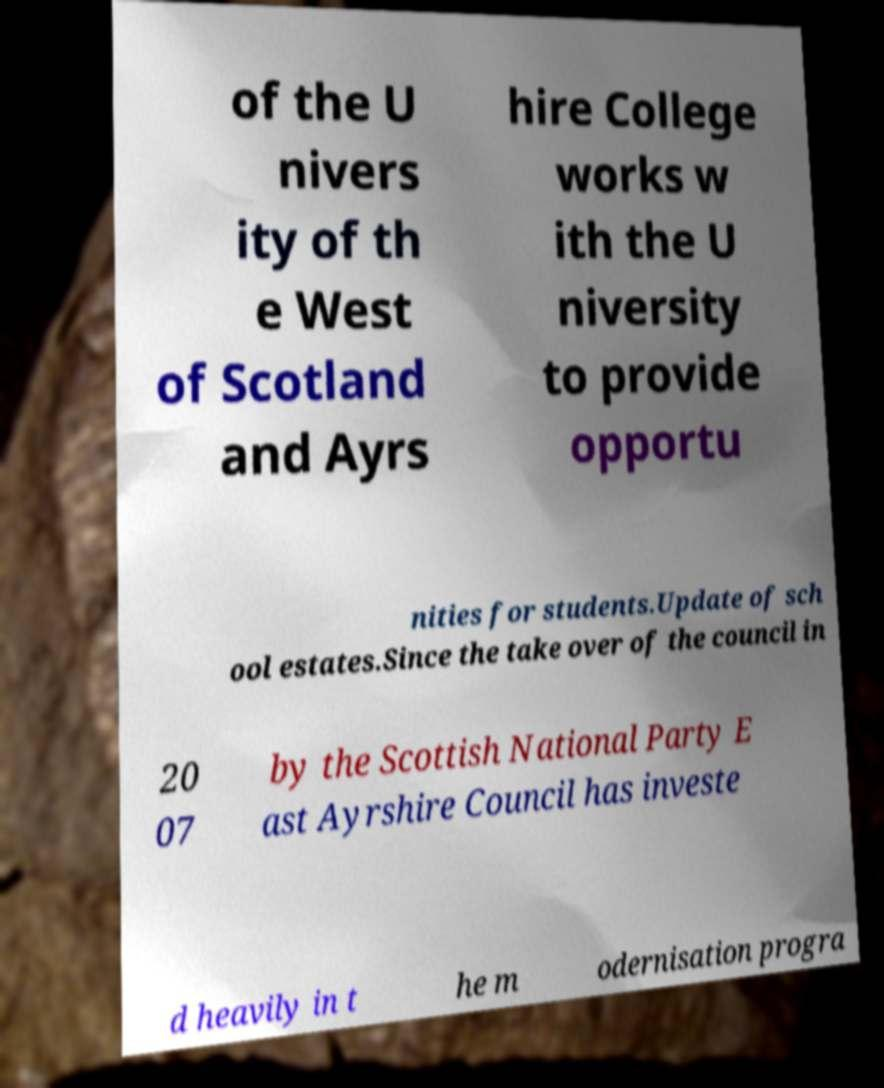There's text embedded in this image that I need extracted. Can you transcribe it verbatim? of the U nivers ity of th e West of Scotland and Ayrs hire College works w ith the U niversity to provide opportu nities for students.Update of sch ool estates.Since the take over of the council in 20 07 by the Scottish National Party E ast Ayrshire Council has investe d heavily in t he m odernisation progra 